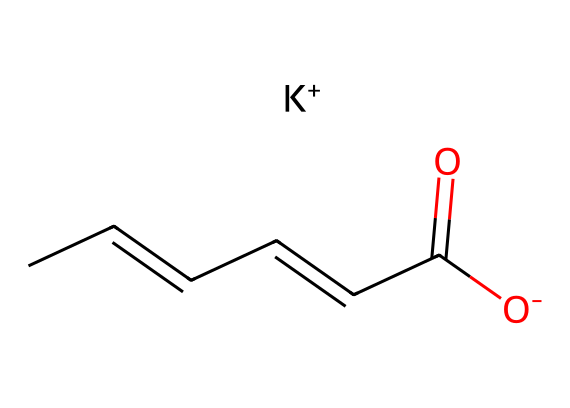What is the chemical name of the compound represented by this SMILES? The SMILES representation provided indicates a structure that is commonly identified as potassium sorbate, which is used as a food preservative.
Answer: potassium sorbate How many carbon atoms are present in this chemical? By inspecting the SMILES, we can count the number of carbon atoms (C). There are six carbon atoms in total.
Answer: 6 What functional group is indicated by the presence of the -COO- in the structure? The -COO- group in the chemical structure denotes a carboxylate, which is the conjugate base of a carboxylic acid. In the case of potassium sorbate, it comes from sorbic acid.
Answer: carboxylate Which organic compound class does potassium sorbate belong to? Potassium sorbate is known primarily as a preservative and can be classified as an unsaturated fatty acid derivative due to its alkene bonds and carboxylate structure.
Answer: unsaturated fatty acid How many double bonds are present in this molecule? The chemical structure shows two double bonds between carbon atoms, which are evident in the CC=CC= portions of the SMILES.
Answer: 2 What role does the potassium ion play in this compound? The potassium ion (K+) in the structure neutralizes the negative charge on the carboxylate group, which enhances the solubility of the compound in food applications.
Answer: solubility 